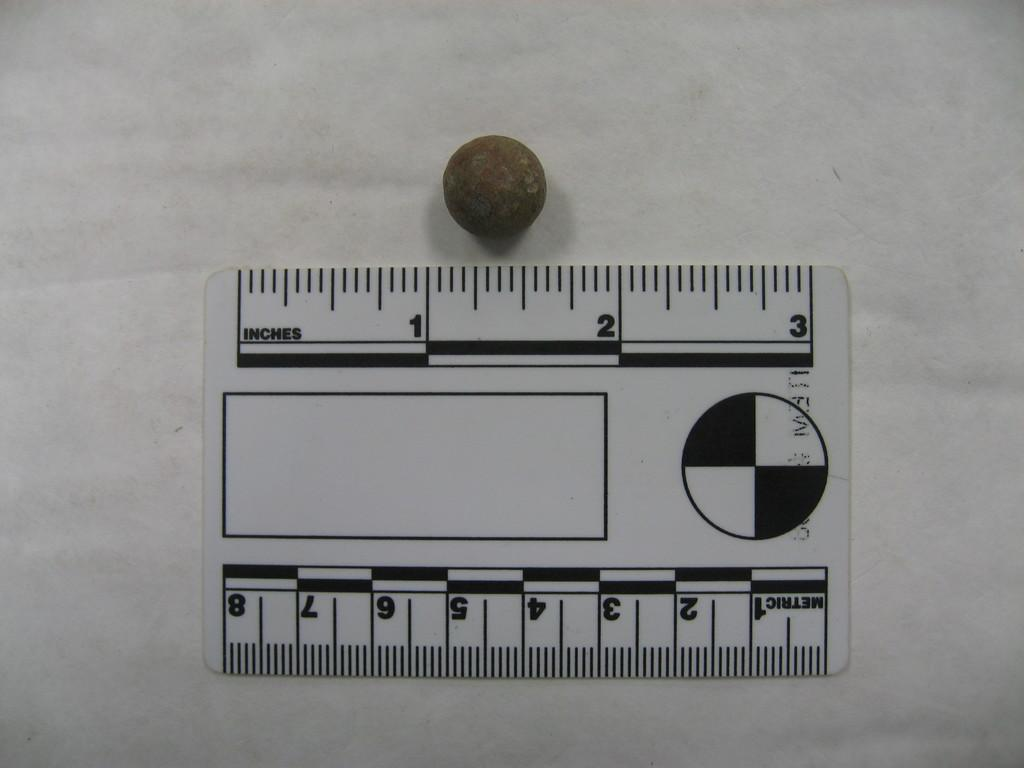Provide a one-sentence caption for the provided image. A small black and white ruler states that it can measure in either inches or metric. 